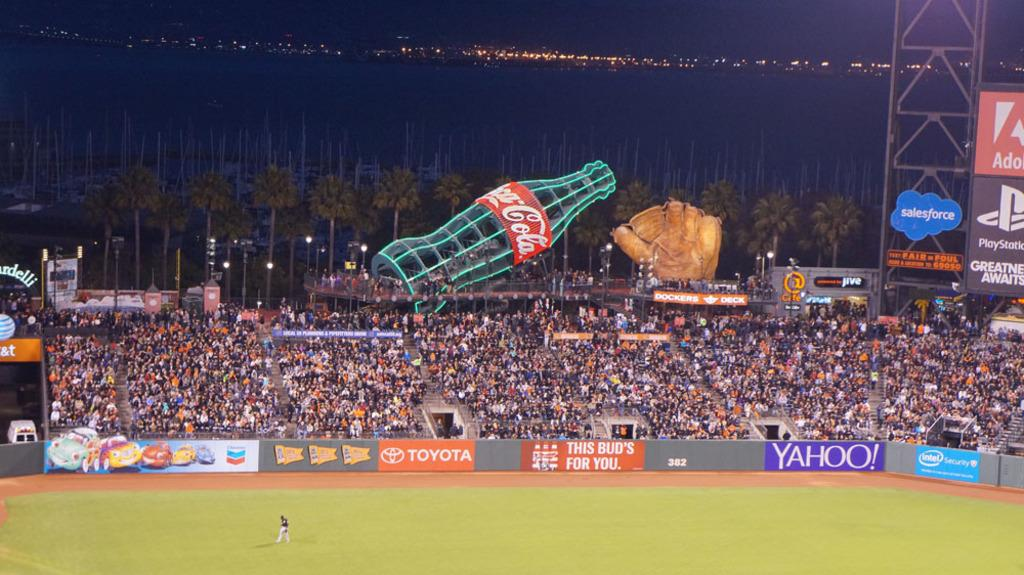<image>
Describe the image concisely. A huge illuminated coca cola bottle rises up behind a crowd of spectators in a sports stadium filled with advertising for Yahoo, Toyota and Play Station and many others. 